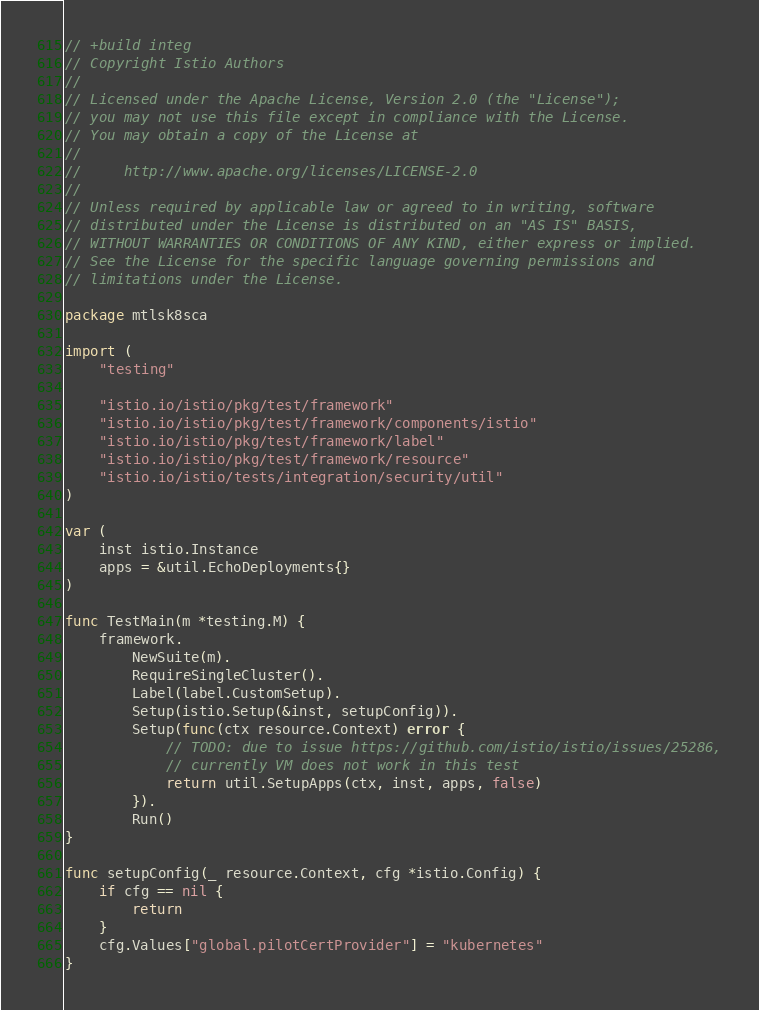<code> <loc_0><loc_0><loc_500><loc_500><_Go_>// +build integ
// Copyright Istio Authors
//
// Licensed under the Apache License, Version 2.0 (the "License");
// you may not use this file except in compliance with the License.
// You may obtain a copy of the License at
//
//     http://www.apache.org/licenses/LICENSE-2.0
//
// Unless required by applicable law or agreed to in writing, software
// distributed under the License is distributed on an "AS IS" BASIS,
// WITHOUT WARRANTIES OR CONDITIONS OF ANY KIND, either express or implied.
// See the License for the specific language governing permissions and
// limitations under the License.

package mtlsk8sca

import (
	"testing"

	"istio.io/istio/pkg/test/framework"
	"istio.io/istio/pkg/test/framework/components/istio"
	"istio.io/istio/pkg/test/framework/label"
	"istio.io/istio/pkg/test/framework/resource"
	"istio.io/istio/tests/integration/security/util"
)

var (
	inst istio.Instance
	apps = &util.EchoDeployments{}
)

func TestMain(m *testing.M) {
	framework.
		NewSuite(m).
		RequireSingleCluster().
		Label(label.CustomSetup).
		Setup(istio.Setup(&inst, setupConfig)).
		Setup(func(ctx resource.Context) error {
			// TODO: due to issue https://github.com/istio/istio/issues/25286,
			// currently VM does not work in this test
			return util.SetupApps(ctx, inst, apps, false)
		}).
		Run()
}

func setupConfig(_ resource.Context, cfg *istio.Config) {
	if cfg == nil {
		return
	}
	cfg.Values["global.pilotCertProvider"] = "kubernetes"
}
</code> 